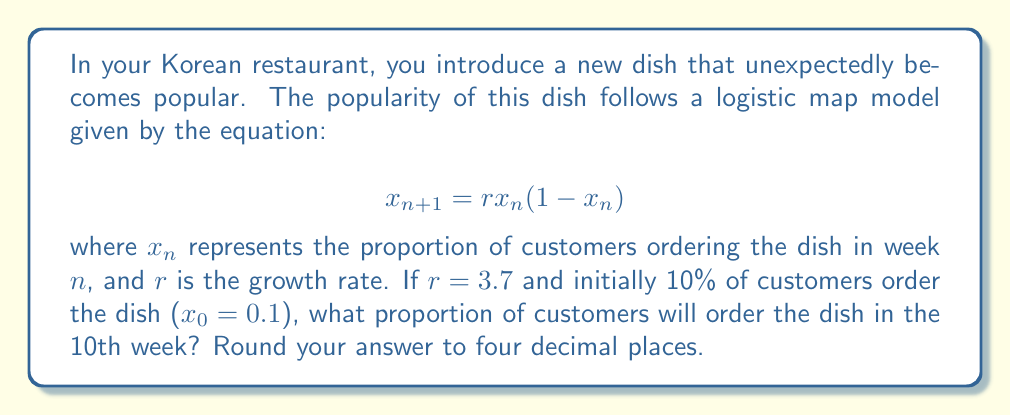Provide a solution to this math problem. To solve this problem, we need to iterate the logistic map equation for 10 weeks:

1) First, let's define our parameters:
   $r = 3.7$
   $x_0 = 0.1$

2) Now, we'll calculate each week's proportion:

   Week 1: $x_1 = 3.7 * 0.1 * (1-0.1) = 0.333$
   
   Week 2: $x_2 = 3.7 * 0.333 * (1-0.333) = 0.8235$
   
   Week 3: $x_3 = 3.7 * 0.8235 * (1-0.8235) = 0.5379$
   
   Week 4: $x_4 = 3.7 * 0.5379 * (1-0.5379) = 0.9196$
   
   Week 5: $x_5 = 3.7 * 0.9196 * (1-0.9196) = 0.2737$
   
   Week 6: $x_6 = 3.7 * 0.2737 * (1-0.2737) = 0.7350$
   
   Week 7: $x_7 = 3.7 * 0.7350 * (1-0.7350) = 0.7199$
   
   Week 8: $x_8 = 3.7 * 0.7199 * (1-0.7199) = 0.7458$
   
   Week 9: $x_9 = 3.7 * 0.7458 * (1-0.7458) = 0.7024$
   
   Week 10: $x_{10} = 3.7 * 0.7024 * (1-0.7024) = 0.7743$

3) Rounding to four decimal places: 0.7743

This result demonstrates the butterfly effect in action. A small initial change (introducing a new dish) led to significant and unpredictable fluctuations in its popularity over time, which would greatly impact inventory management.
Answer: 0.7743 